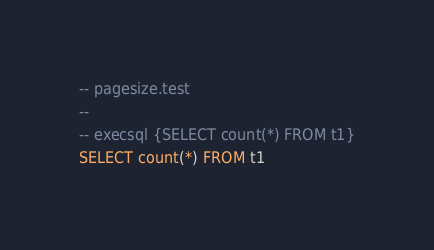<code> <loc_0><loc_0><loc_500><loc_500><_SQL_>-- pagesize.test
-- 
-- execsql {SELECT count(*) FROM t1}
SELECT count(*) FROM t1</code> 